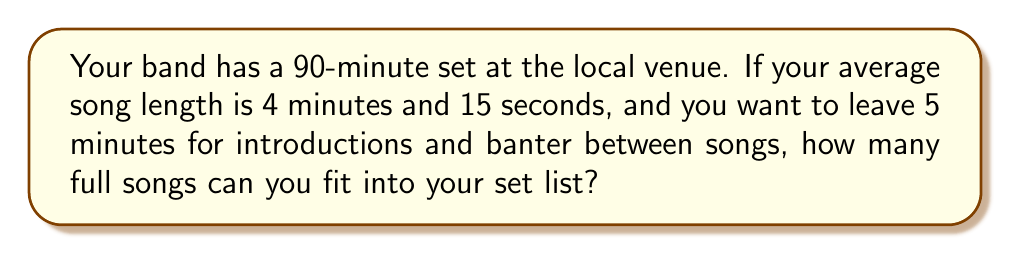Provide a solution to this math problem. Let's approach this step-by-step:

1. Convert the total set time to minutes:
   90 minutes

2. Subtract the time for introductions and banter:
   $90 - 5 = 85$ minutes available for songs

3. Convert the average song length to minutes:
   4 minutes and 15 seconds = 4.25 minutes

4. Calculate the number of songs that can fit:
   $\text{Number of songs} = \frac{\text{Available time}}{\text{Average song length}}$
   
   $\text{Number of songs} = \frac{85}{4.25} = 20$

5. Since we can only play full songs, we round down to the nearest whole number:
   20 full songs

Therefore, you can fit 20 full songs into your set list.
Answer: 20 songs 